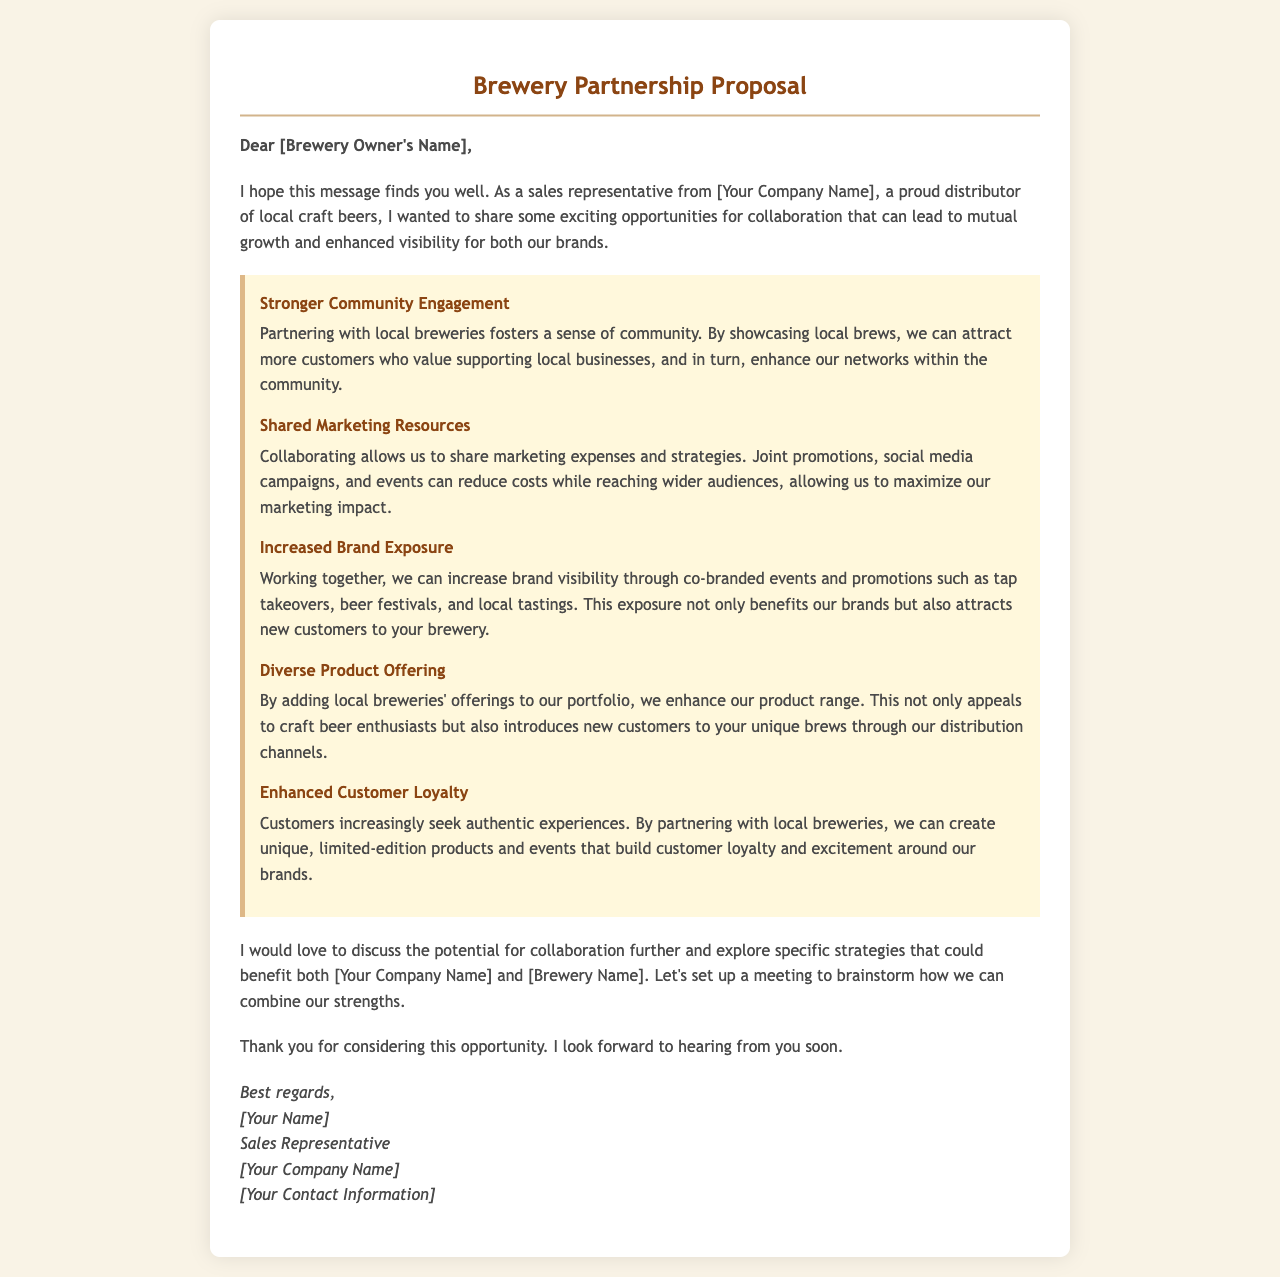what is the title of the document? The title of the document is found in the <title> tag of the HTML, stating the purpose of the letter.
Answer: Brewery Partnership Proposal who is the greeting addressed to? The greeting is directed to the owner of the brewery, indicated by the placeholder in the greeting section.
Answer: [Brewery Owner's Name] what is one benefit of partnering with local breweries? The document lists several benefits under a specific section that helps highlight reasons for collaboration.
Answer: Stronger Community Engagement how does the document suggest increasing brand exposure? The document explains the strategy for enhanced brand visibility through events and promotions mentioned in the benefits section.
Answer: Co-branded events what is the closing statement of the letter? The closing statement summarizes the intention of future communication and expresses expectation for a response, which is part of the letter structure.
Answer: Thank you for considering this opportunity what is the main purpose of the letter? The overall purpose of the letter is detailed in the introduction, clarifying its intent to promote collaboration.
Answer: Mutual growth and enhanced visibility 